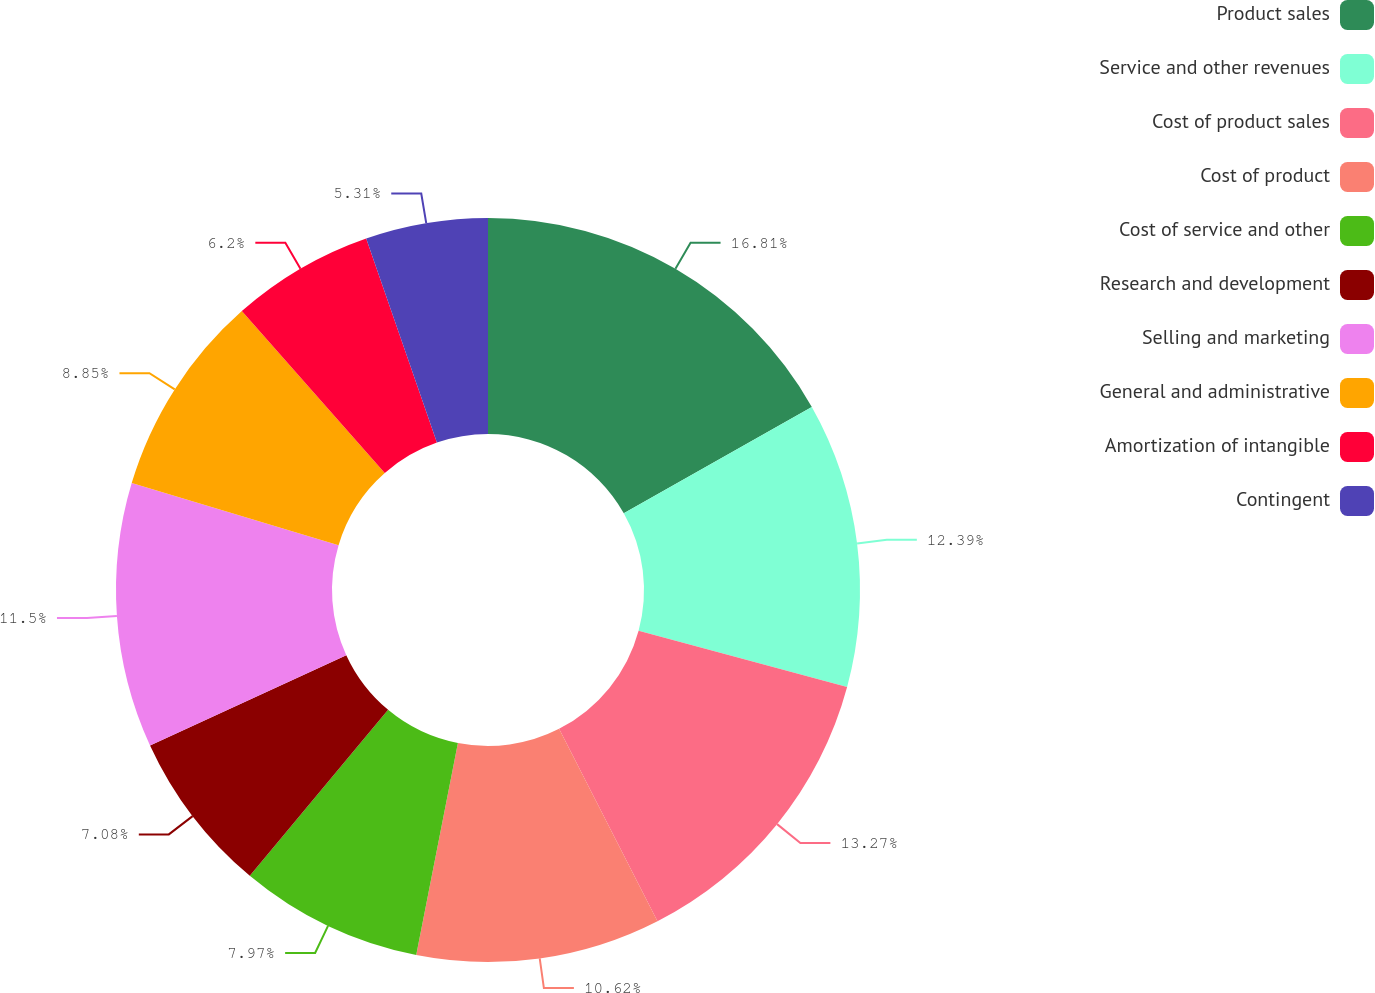<chart> <loc_0><loc_0><loc_500><loc_500><pie_chart><fcel>Product sales<fcel>Service and other revenues<fcel>Cost of product sales<fcel>Cost of product<fcel>Cost of service and other<fcel>Research and development<fcel>Selling and marketing<fcel>General and administrative<fcel>Amortization of intangible<fcel>Contingent<nl><fcel>16.81%<fcel>12.39%<fcel>13.27%<fcel>10.62%<fcel>7.97%<fcel>7.08%<fcel>11.5%<fcel>8.85%<fcel>6.2%<fcel>5.31%<nl></chart> 